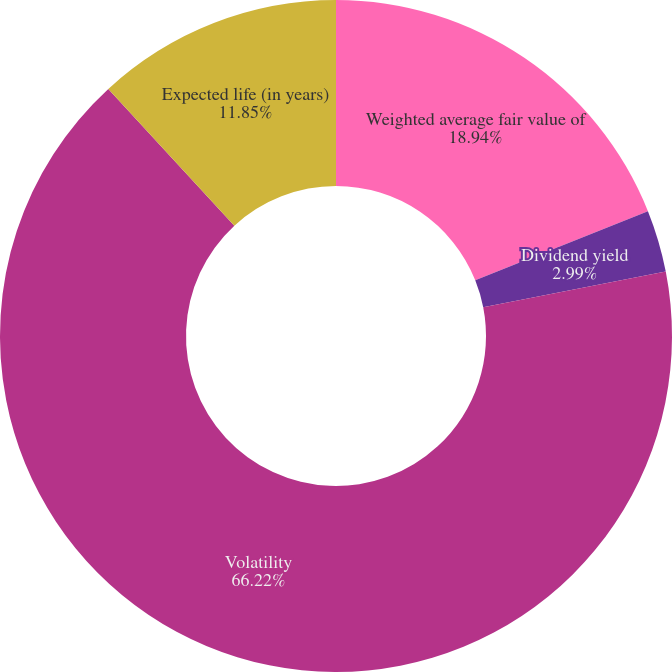Convert chart to OTSL. <chart><loc_0><loc_0><loc_500><loc_500><pie_chart><fcel>Weighted average fair value of<fcel>Dividend yield<fcel>Volatility<fcel>Expected life (in years)<nl><fcel>18.94%<fcel>2.99%<fcel>66.22%<fcel>11.85%<nl></chart> 